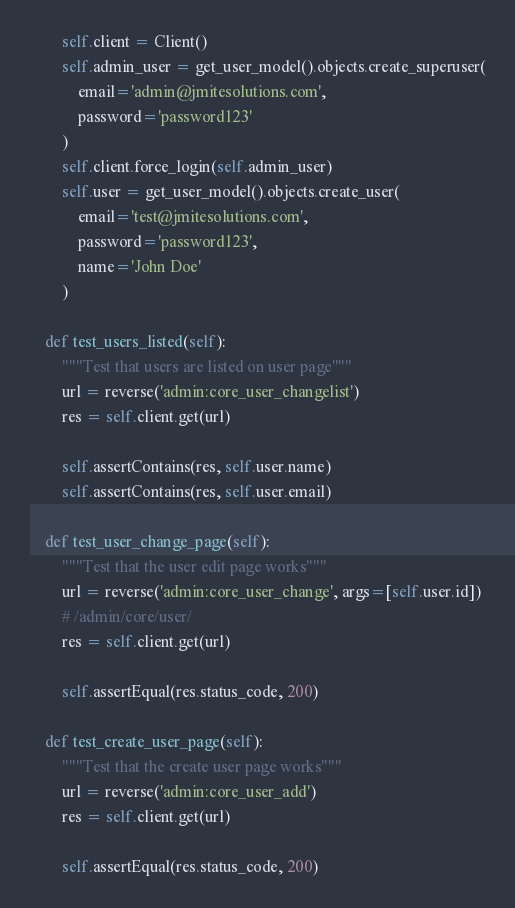Convert code to text. <code><loc_0><loc_0><loc_500><loc_500><_Python_>        self.client = Client()
        self.admin_user = get_user_model().objects.create_superuser(
            email='admin@jmitesolutions.com',
            password='password123'
        )
        self.client.force_login(self.admin_user)
        self.user = get_user_model().objects.create_user(
            email='test@jmitesolutions.com',
            password='password123',
            name='John Doe'
        )

    def test_users_listed(self):
        """Test that users are listed on user page"""
        url = reverse('admin:core_user_changelist')
        res = self.client.get(url)

        self.assertContains(res, self.user.name)
        self.assertContains(res, self.user.email)

    def test_user_change_page(self):
        """Test that the user edit page works"""
        url = reverse('admin:core_user_change', args=[self.user.id])
        # /admin/core/user/
        res = self.client.get(url)

        self.assertEqual(res.status_code, 200)

    def test_create_user_page(self):
        """Test that the create user page works"""
        url = reverse('admin:core_user_add')
        res = self.client.get(url)

        self.assertEqual(res.status_code, 200)
</code> 